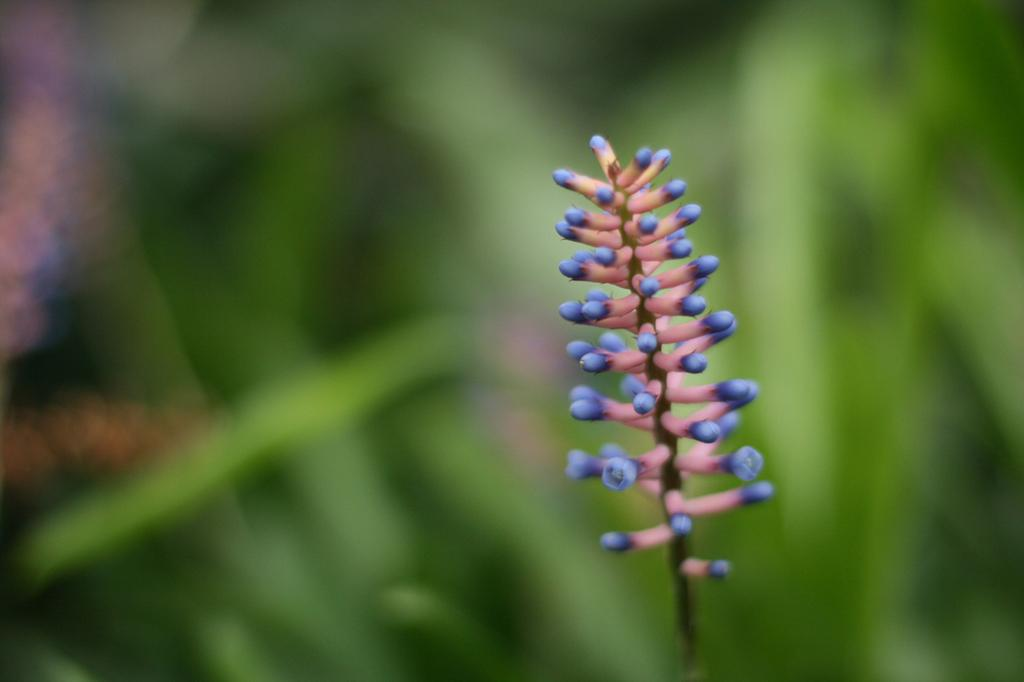What is the main subject in the front of the image? There is a plant in the front of the image. Can you describe the background of the image? The background of the image is blurry. Where is the scarecrow located in the image? There is no scarecrow present in the image. What type of sea creatures can be seen swimming in the image? There is no sea or sea creatures present in the image. 